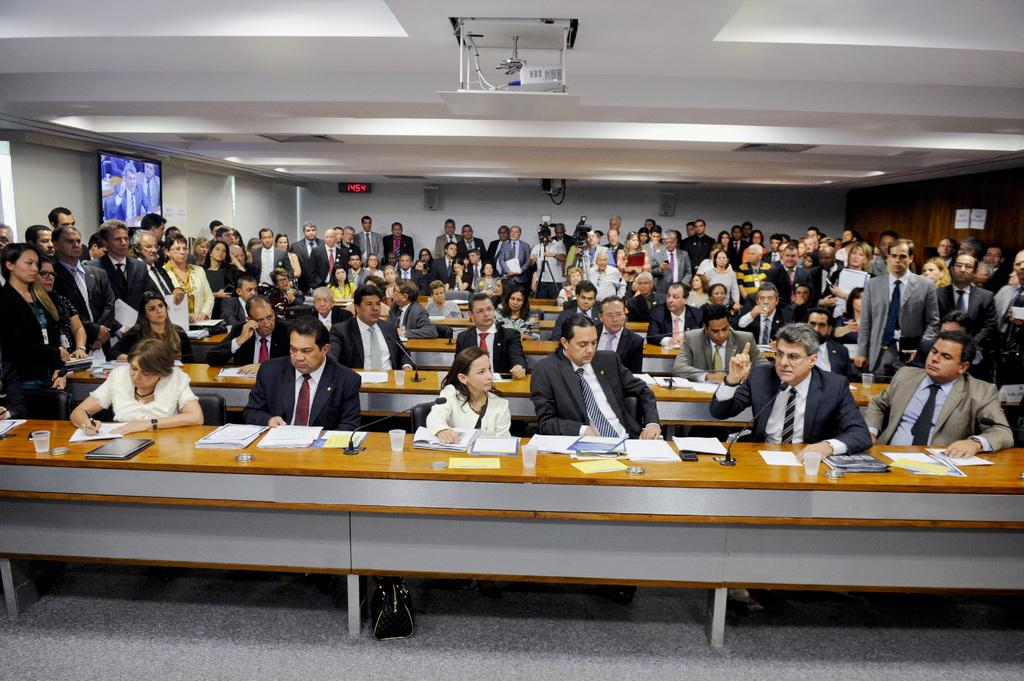How many people are in the image? There are people in the image, but the exact number is not specified. What are some people doing in the image? Some people are sitting on a table, while most people are standing. What can be seen in the background of the image? There is a projector in the background. Is there any indication of time in the image? Yes, there is a clock in the image. How does the glove help the people in the image during the rainstorm? There is no mention of a glove or a rainstorm in the image, so this question cannot be answered. 